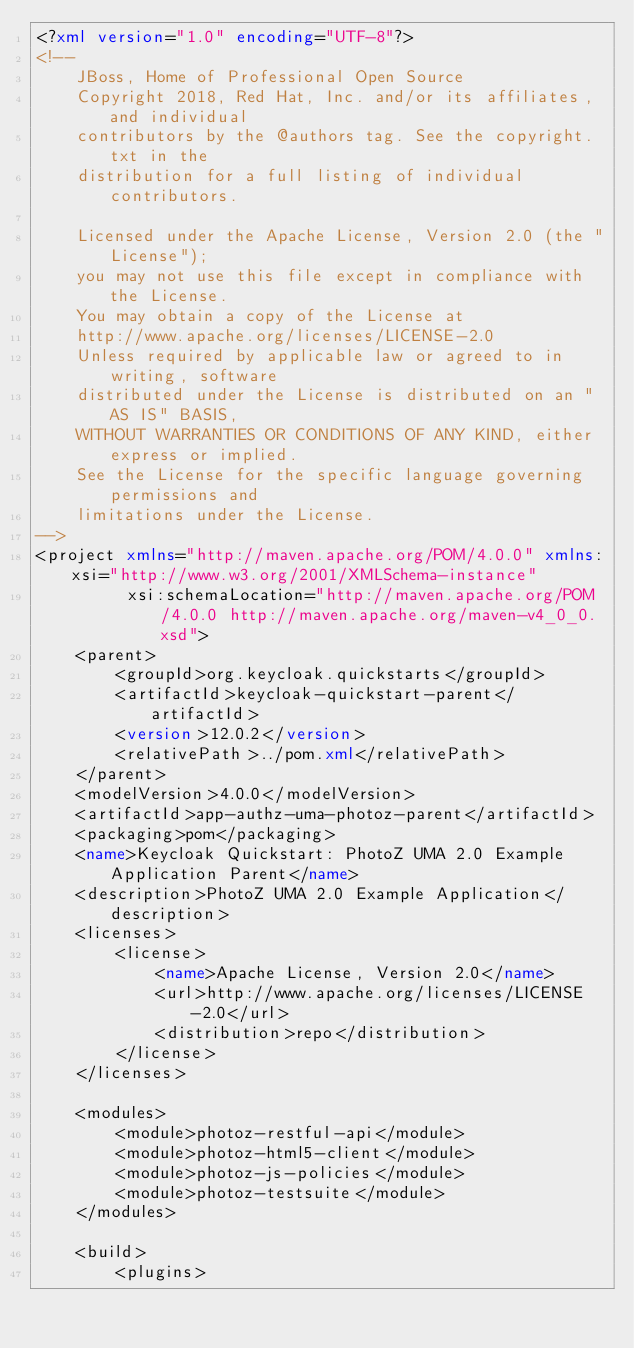Convert code to text. <code><loc_0><loc_0><loc_500><loc_500><_XML_><?xml version="1.0" encoding="UTF-8"?>
<!--
    JBoss, Home of Professional Open Source
    Copyright 2018, Red Hat, Inc. and/or its affiliates, and individual
    contributors by the @authors tag. See the copyright.txt in the
    distribution for a full listing of individual contributors.

    Licensed under the Apache License, Version 2.0 (the "License");
    you may not use this file except in compliance with the License.
    You may obtain a copy of the License at
    http://www.apache.org/licenses/LICENSE-2.0
    Unless required by applicable law or agreed to in writing, software
    distributed under the License is distributed on an "AS IS" BASIS,
    WITHOUT WARRANTIES OR CONDITIONS OF ANY KIND, either express or implied.
    See the License for the specific language governing permissions and
    limitations under the License.
-->
<project xmlns="http://maven.apache.org/POM/4.0.0" xmlns:xsi="http://www.w3.org/2001/XMLSchema-instance"
         xsi:schemaLocation="http://maven.apache.org/POM/4.0.0 http://maven.apache.org/maven-v4_0_0.xsd">
    <parent>
        <groupId>org.keycloak.quickstarts</groupId>
        <artifactId>keycloak-quickstart-parent</artifactId>
        <version>12.0.2</version>
        <relativePath>../pom.xml</relativePath>
    </parent>
    <modelVersion>4.0.0</modelVersion>
    <artifactId>app-authz-uma-photoz-parent</artifactId>
    <packaging>pom</packaging>
    <name>Keycloak Quickstart: PhotoZ UMA 2.0 Example Application Parent</name>
    <description>PhotoZ UMA 2.0 Example Application</description>
    <licenses>
        <license>
            <name>Apache License, Version 2.0</name>
            <url>http://www.apache.org/licenses/LICENSE-2.0</url>
            <distribution>repo</distribution>
        </license>
    </licenses>

    <modules>
        <module>photoz-restful-api</module>
        <module>photoz-html5-client</module>
        <module>photoz-js-policies</module>
        <module>photoz-testsuite</module>
    </modules>

    <build>
        <plugins></code> 